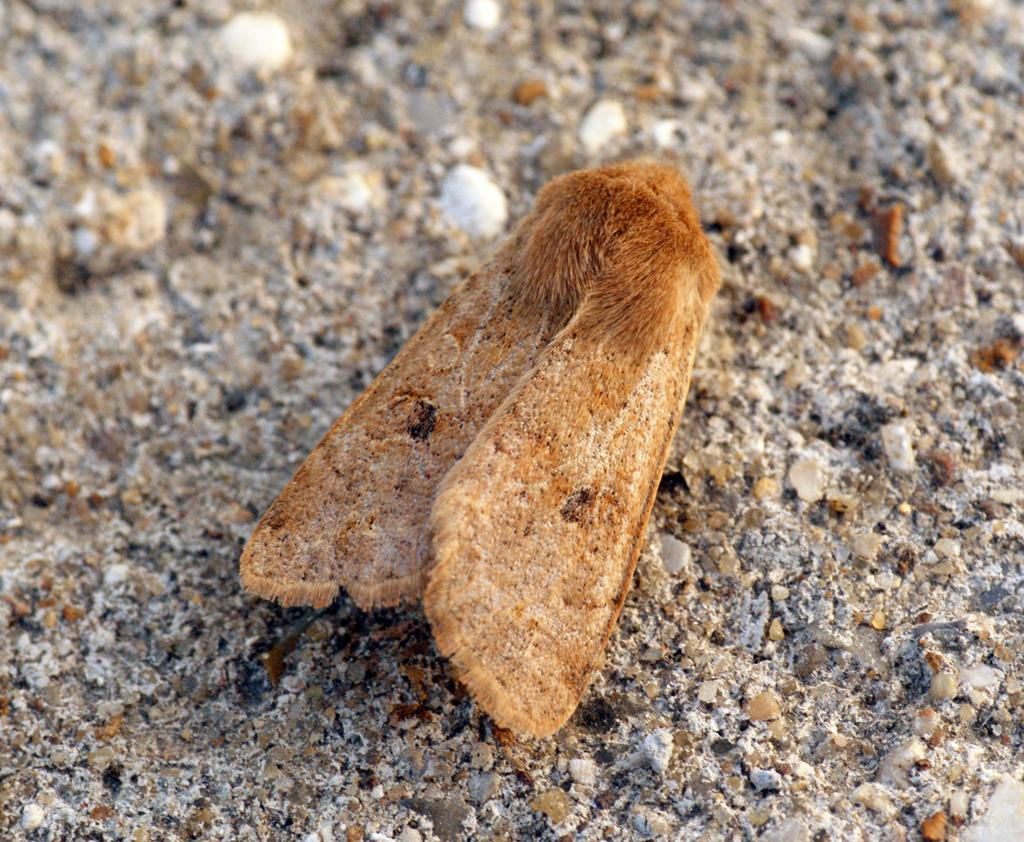What type of creature can be seen in the image? There is an insect in the image. Where is the insect located? The insect is on a path. What type of cart is being used to transport the shock in the image? There is no cart or shock present in the image; it only features an insect on a path. 